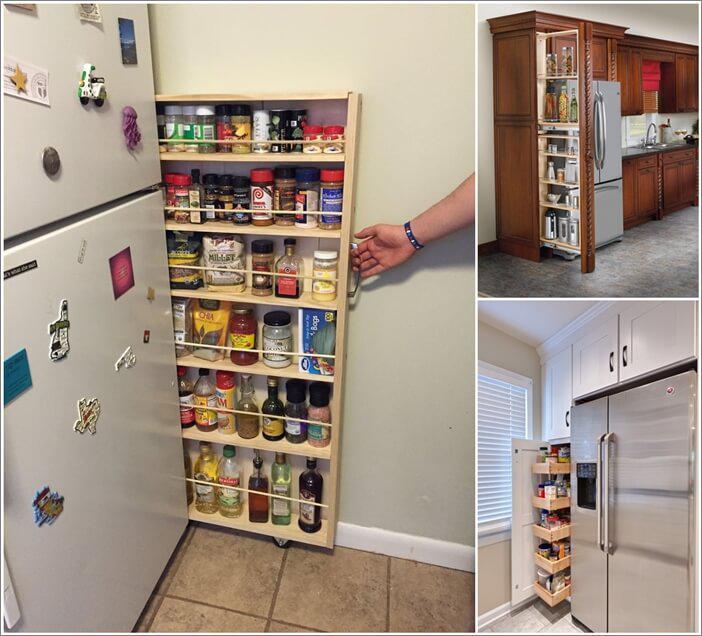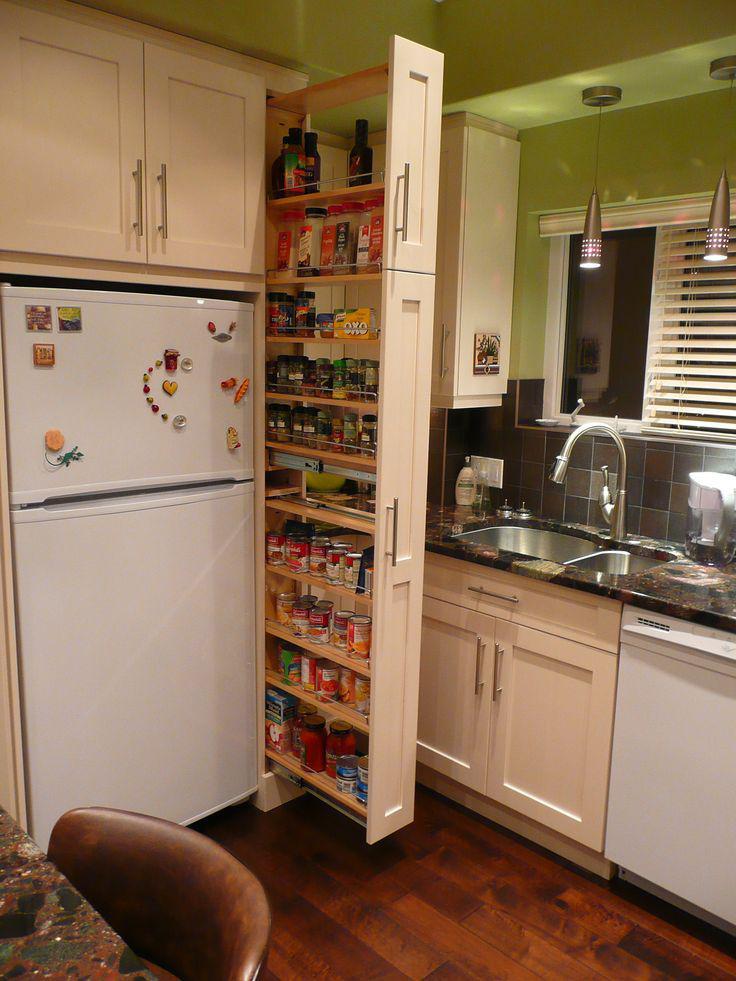The first image is the image on the left, the second image is the image on the right. Assess this claim about the two images: "The right image shows a narrow filled pantry with a handle pulled out from behind a stainless steel refrigerator and in front of a doorway.". Correct or not? Answer yes or no. No. 